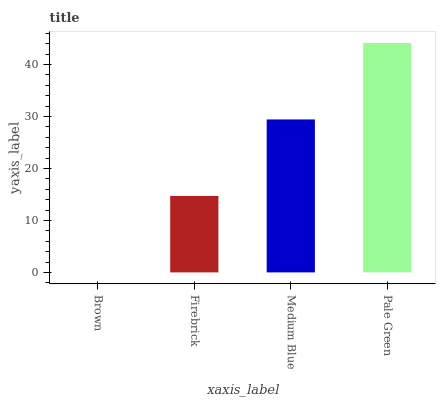Is Brown the minimum?
Answer yes or no. Yes. Is Pale Green the maximum?
Answer yes or no. Yes. Is Firebrick the minimum?
Answer yes or no. No. Is Firebrick the maximum?
Answer yes or no. No. Is Firebrick greater than Brown?
Answer yes or no. Yes. Is Brown less than Firebrick?
Answer yes or no. Yes. Is Brown greater than Firebrick?
Answer yes or no. No. Is Firebrick less than Brown?
Answer yes or no. No. Is Medium Blue the high median?
Answer yes or no. Yes. Is Firebrick the low median?
Answer yes or no. Yes. Is Brown the high median?
Answer yes or no. No. Is Medium Blue the low median?
Answer yes or no. No. 